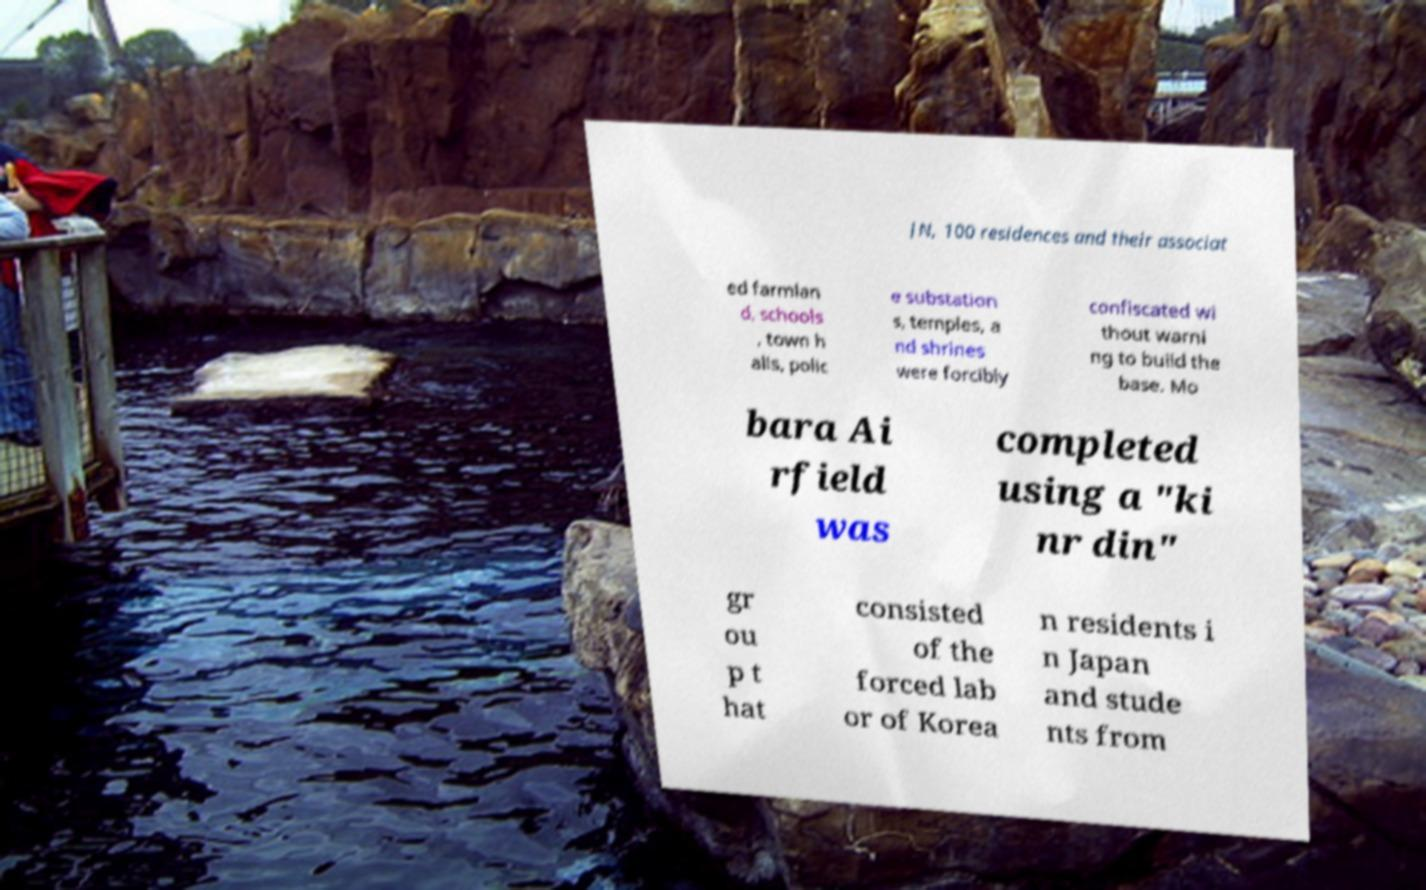What messages or text are displayed in this image? I need them in a readable, typed format. JN, 100 residences and their associat ed farmlan d, schools , town h alls, polic e substation s, temples, a nd shrines were forcibly confiscated wi thout warni ng to build the base. Mo bara Ai rfield was completed using a "ki nr din" gr ou p t hat consisted of the forced lab or of Korea n residents i n Japan and stude nts from 